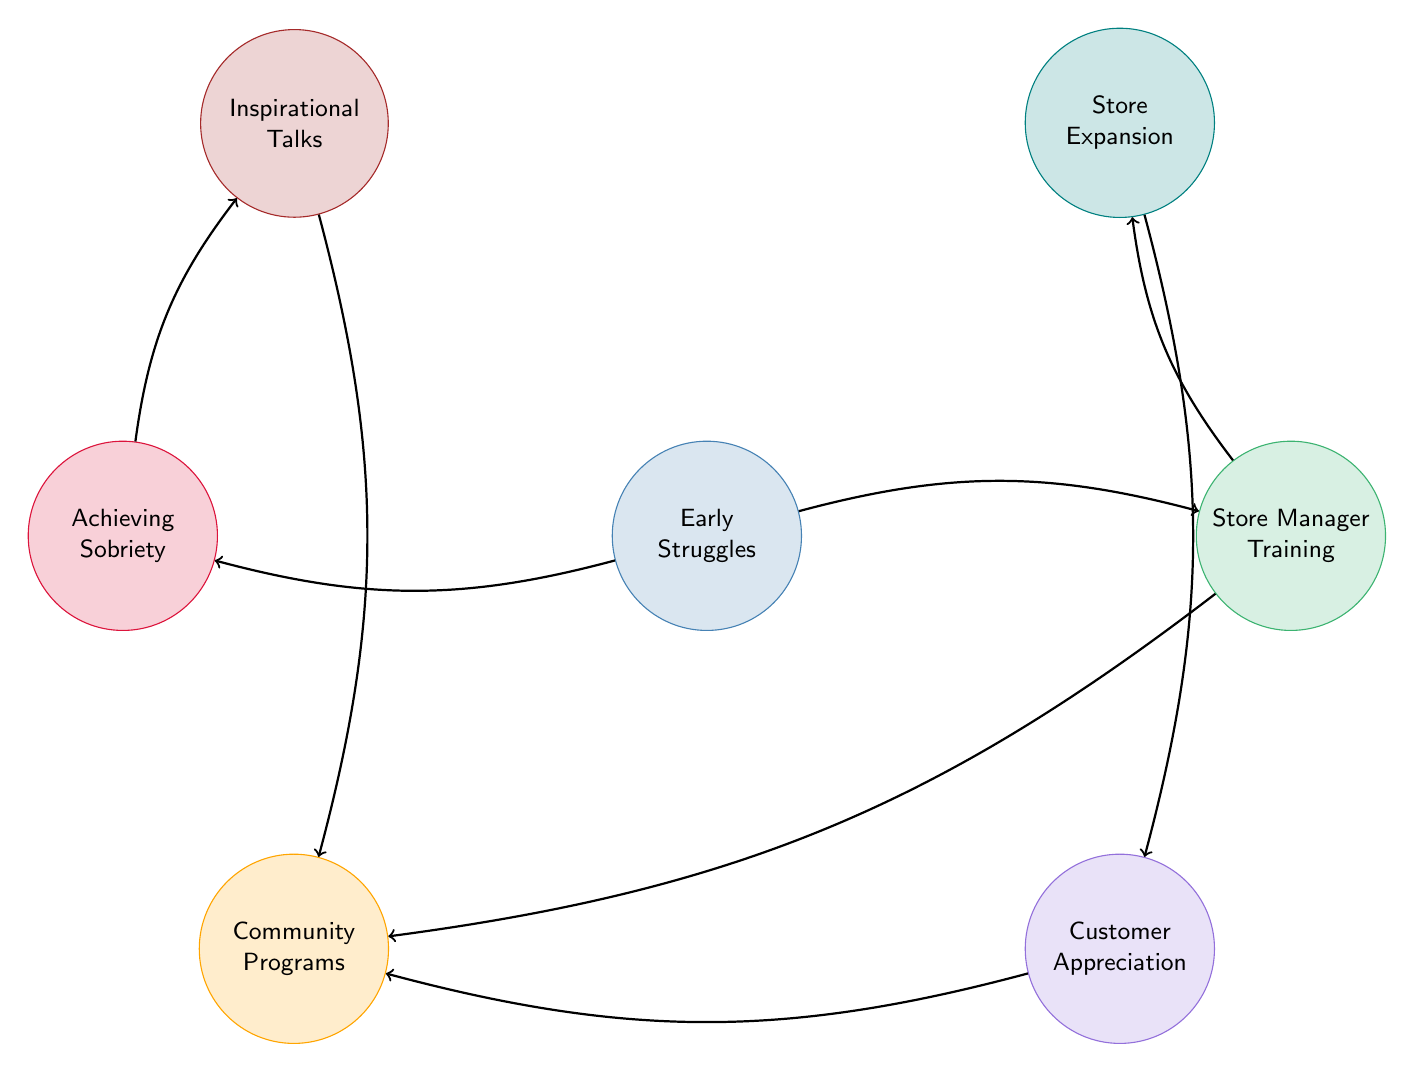What is the total number of nodes in the diagram? The diagram has a total of 7 nodes, which are Early Struggles, Store Manager Training, Customer Appreciation, Community Programs, Achieving Sobriety, Store Expansion, and Inspirational Talks.
Answer: 7 Which node connects Early Struggles and Achieving Sobriety? The node that connects Early Struggles and Achieving Sobriety in the diagram is the direct link from Early Struggles to Achieving Sobriety.
Answer: Achieving Sobriety What is the relationship between Store Manager Training and Community Programs? The diagram shows a direct link between Store Manager Training and Community Programs, indicating a connection where Store Manager Training may lead to involvement in Community Programs.
Answer: Connection How many direct connections are there from Store Manager Training? Store Manager Training has 2 direct connections: one to Store Expansion and one to Community Programs.
Answer: 2 Which two nodes share a connection through Inspirational Talks? Inspirational Talks connects to Achieving Sobriety and Community Programs, thus the two nodes sharing a connection through Inspirational Talks are these two nodes.
Answer: Achieving Sobriety and Community Programs What is the primary milestone achieved after Early Struggles according to the diagram? According to the diagram, the primary milestone achieved after Early Struggles is Achieving Sobriety, suggesting a significant turning point in the journey.
Answer: Achieving Sobriety Which node is reached by the link from Store Expansion? The link from Store Expansion connects to Customer Appreciation, showing how the expansion effort can lead to appreciation from customers.
Answer: Customer Appreciation In which phase does the Grocery Store Manager start training? The Grocery Store Manager begins training after going through Early Struggles, which is identified in the diagram as a foundational step.
Answer: Store Manager Training 